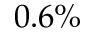Convert formula to latex. <formula><loc_0><loc_0><loc_500><loc_500>0 . 6 \%</formula> 